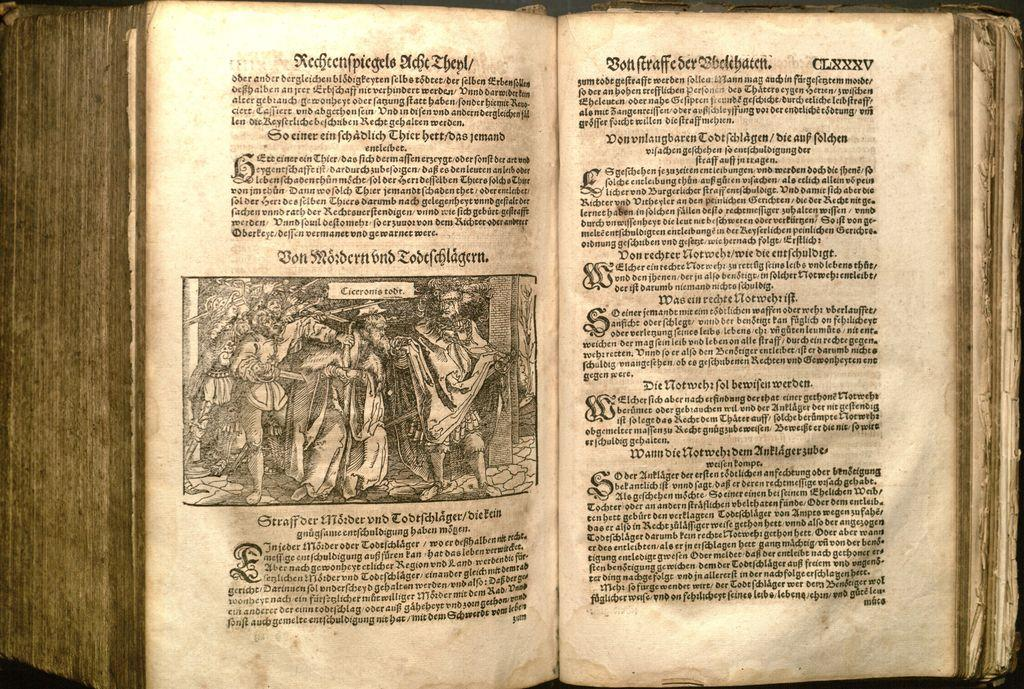<image>
Render a clear and concise summary of the photo. A vintage book is opened to page CLXXXV, marked in the upper right corner. 